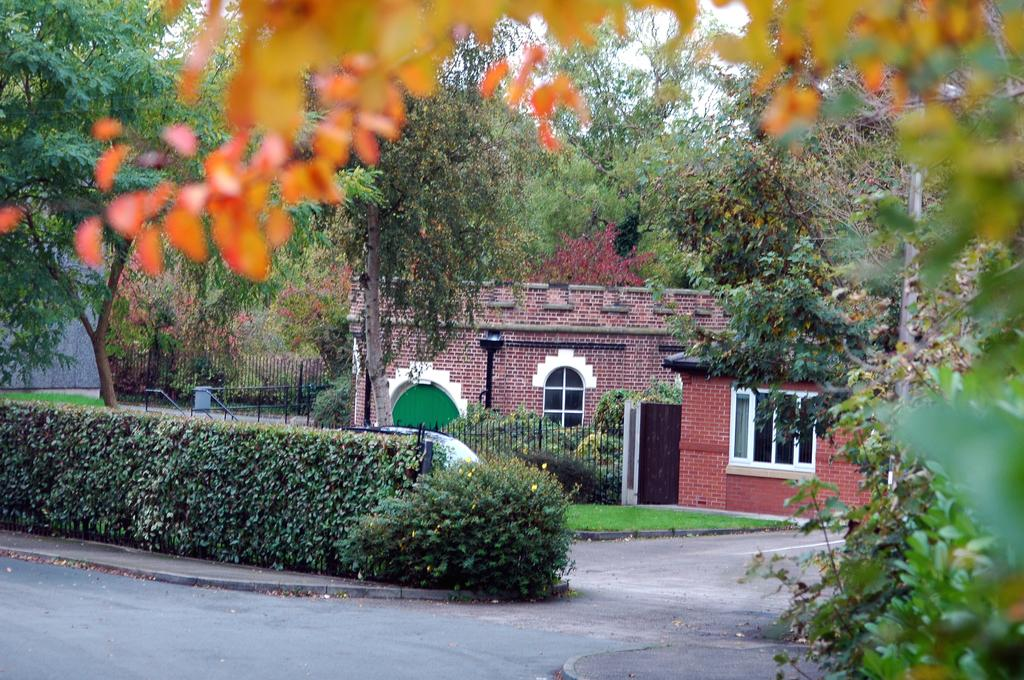What features can be seen on the house in the image? The house has windows and a door. What is in front of the house? There is a fence, grass, plants, and trees in front of the house. What type of fowl can be seen connecting the trees in the image? There is no fowl present in the image, and no fowl is connecting the trees. Can you describe the person standing in front of the house in the image? There is no person present in the image; only the house, fence, grass, plants, and trees are visible. 